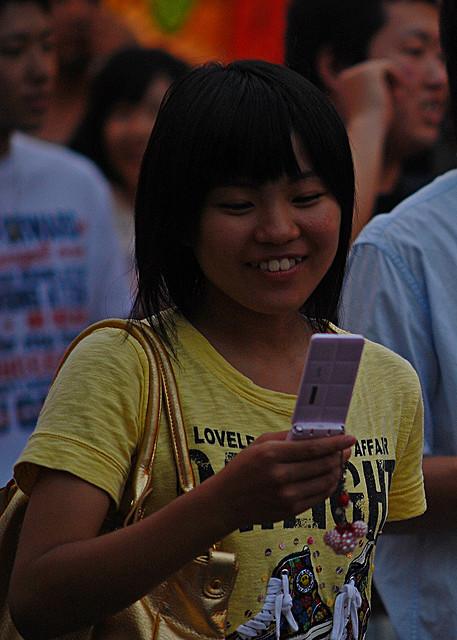What color is the girl's shirt?
Give a very brief answer. Yellow. Is this person looking at a video screen?
Be succinct. Yes. Why does the man in the upper right portion of the photo have his hand at his face?
Give a very brief answer. Phone. What is the girl holding?
Answer briefly. Phone. What is the woman holding in her right hand?
Write a very short answer. Phone. 